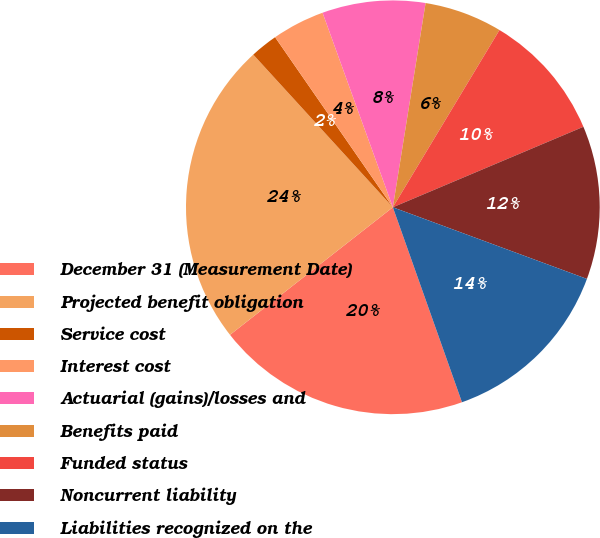Convert chart to OTSL. <chart><loc_0><loc_0><loc_500><loc_500><pie_chart><fcel>December 31 (Measurement Date)<fcel>Projected benefit obligation<fcel>Service cost<fcel>Interest cost<fcel>Actuarial (gains)/losses and<fcel>Benefits paid<fcel>Funded status<fcel>Noncurrent liability<fcel>Liabilities recognized on the<nl><fcel>19.85%<fcel>23.79%<fcel>2.15%<fcel>4.12%<fcel>8.05%<fcel>6.09%<fcel>10.02%<fcel>11.99%<fcel>13.95%<nl></chart> 